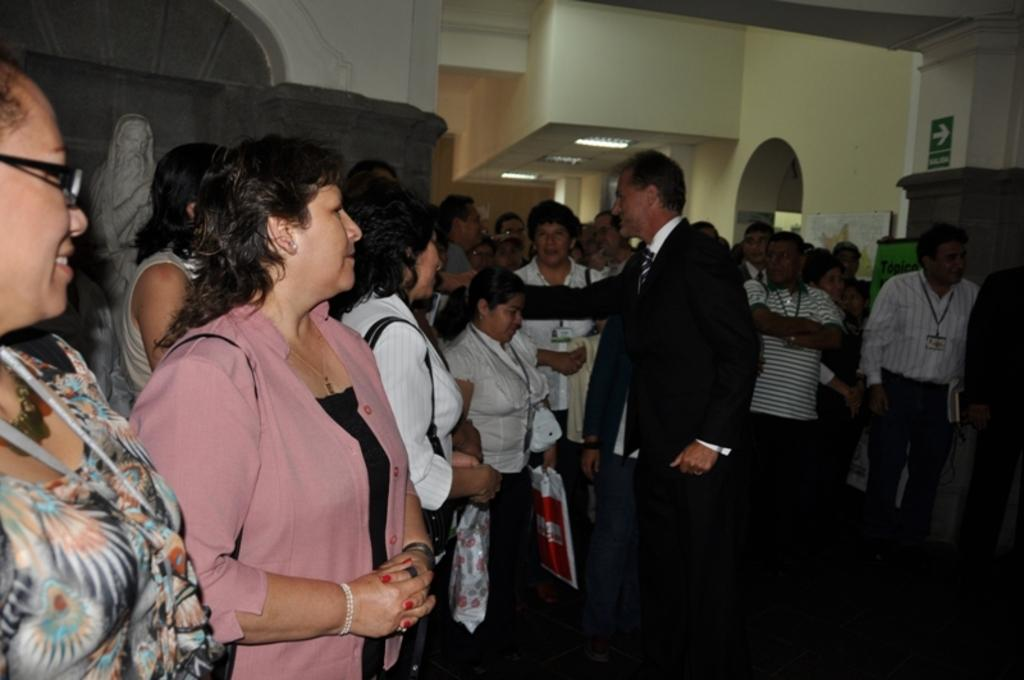How many people are in the group visible in the image? There is a group of people standing in the image, but the exact number cannot be determined from the provided facts. What objects are present in the image besides the people? There are boards, walls, lights, and a sculpture visible in the image. What type of lighting is present in the image? There are lights in the image, but their specific type or arrangement cannot be determined from the provided facts. What is the purpose of the boards in the image? The purpose of the boards in the image cannot be determined from the provided facts. What type of powder is being used to create the structure in the image? There is no structure or powder present in the image; it features a group of people, boards, walls, lights, and a sculpture. 